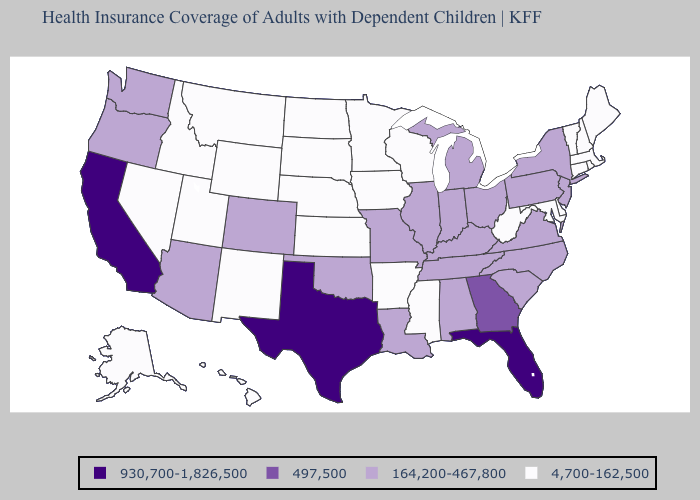Name the states that have a value in the range 497,500?
Keep it brief. Georgia. What is the lowest value in the West?
Keep it brief. 4,700-162,500. What is the lowest value in the USA?
Quick response, please. 4,700-162,500. Name the states that have a value in the range 497,500?
Keep it brief. Georgia. Which states have the lowest value in the USA?
Keep it brief. Alaska, Arkansas, Connecticut, Delaware, Hawaii, Idaho, Iowa, Kansas, Maine, Maryland, Massachusetts, Minnesota, Mississippi, Montana, Nebraska, Nevada, New Hampshire, New Mexico, North Dakota, Rhode Island, South Dakota, Utah, Vermont, West Virginia, Wisconsin, Wyoming. Does New York have a higher value than Alabama?
Keep it brief. No. Among the states that border Pennsylvania , which have the highest value?
Write a very short answer. New Jersey, New York, Ohio. Name the states that have a value in the range 930,700-1,826,500?
Keep it brief. California, Florida, Texas. Does Ohio have the same value as Missouri?
Answer briefly. Yes. Which states have the highest value in the USA?
Write a very short answer. California, Florida, Texas. Name the states that have a value in the range 930,700-1,826,500?
Answer briefly. California, Florida, Texas. Does New York have a lower value than Hawaii?
Be succinct. No. Name the states that have a value in the range 930,700-1,826,500?
Keep it brief. California, Florida, Texas. What is the value of Arkansas?
Quick response, please. 4,700-162,500. Which states hav the highest value in the MidWest?
Short answer required. Illinois, Indiana, Michigan, Missouri, Ohio. 